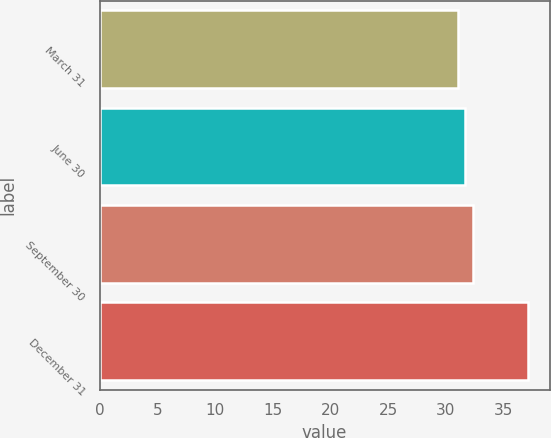Convert chart. <chart><loc_0><loc_0><loc_500><loc_500><bar_chart><fcel>March 31<fcel>June 30<fcel>September 30<fcel>December 31<nl><fcel>31.02<fcel>31.63<fcel>32.38<fcel>37.15<nl></chart> 